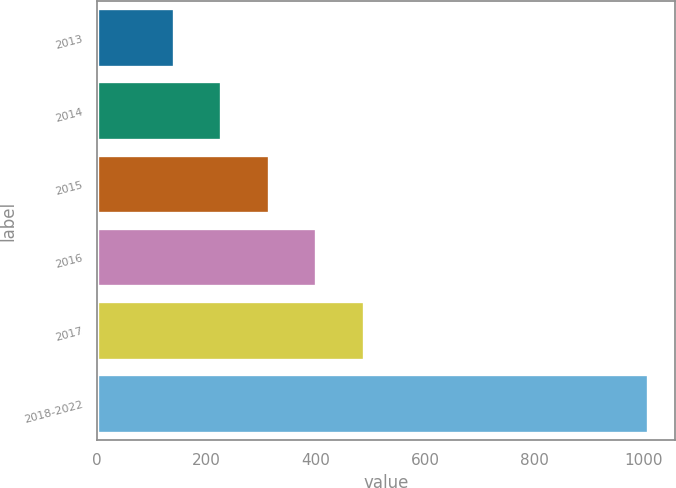<chart> <loc_0><loc_0><loc_500><loc_500><bar_chart><fcel>2013<fcel>2014<fcel>2015<fcel>2016<fcel>2017<fcel>2018-2022<nl><fcel>141<fcel>227.6<fcel>314.2<fcel>400.8<fcel>487.4<fcel>1007<nl></chart> 